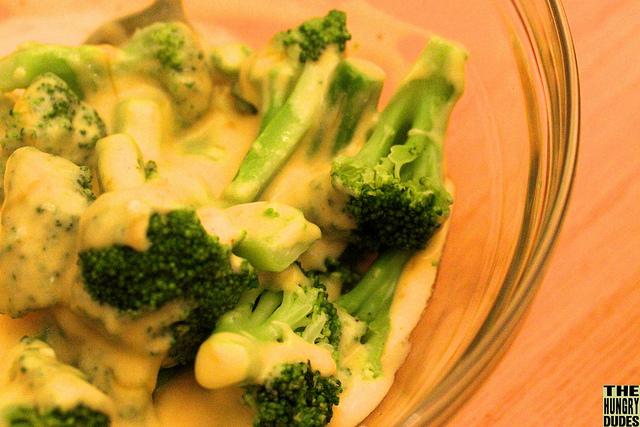What is the table made of?
Concise answer only. Wood. What color is the bowl?
Be succinct. Clear. What type of sauce is shown?
Write a very short answer. Cheese. 